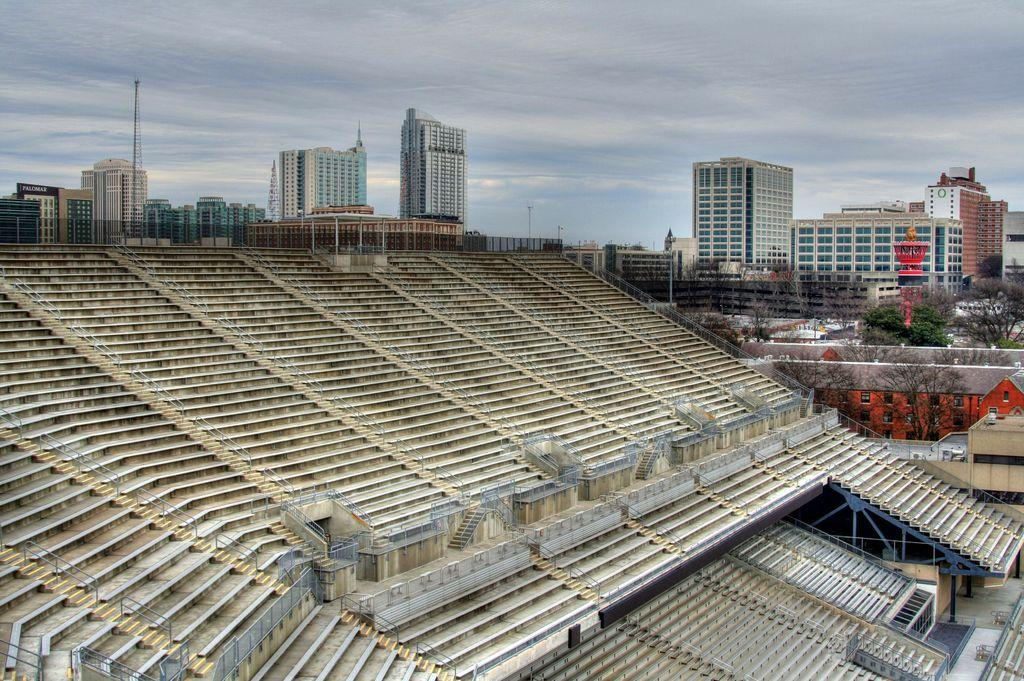What is the main subject in the center of the image? There are steps in the center of the image. What can be seen in the background of the image? There are buildings and trees in the background of the image. How would you describe the sky in the image? The sky is cloudy in the image. How many legs does the jelly have in the image? There is no jelly present in the image, so it does not have any legs. 